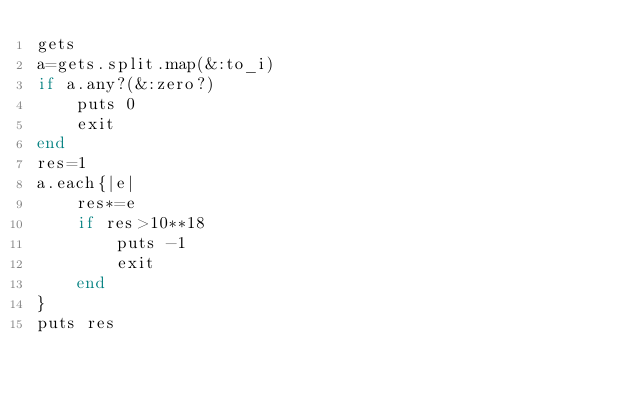<code> <loc_0><loc_0><loc_500><loc_500><_Ruby_>gets
a=gets.split.map(&:to_i)
if a.any?(&:zero?)
    puts 0
    exit
end
res=1
a.each{|e|
    res*=e
    if res>10**18
        puts -1
        exit
    end
}
puts res
</code> 